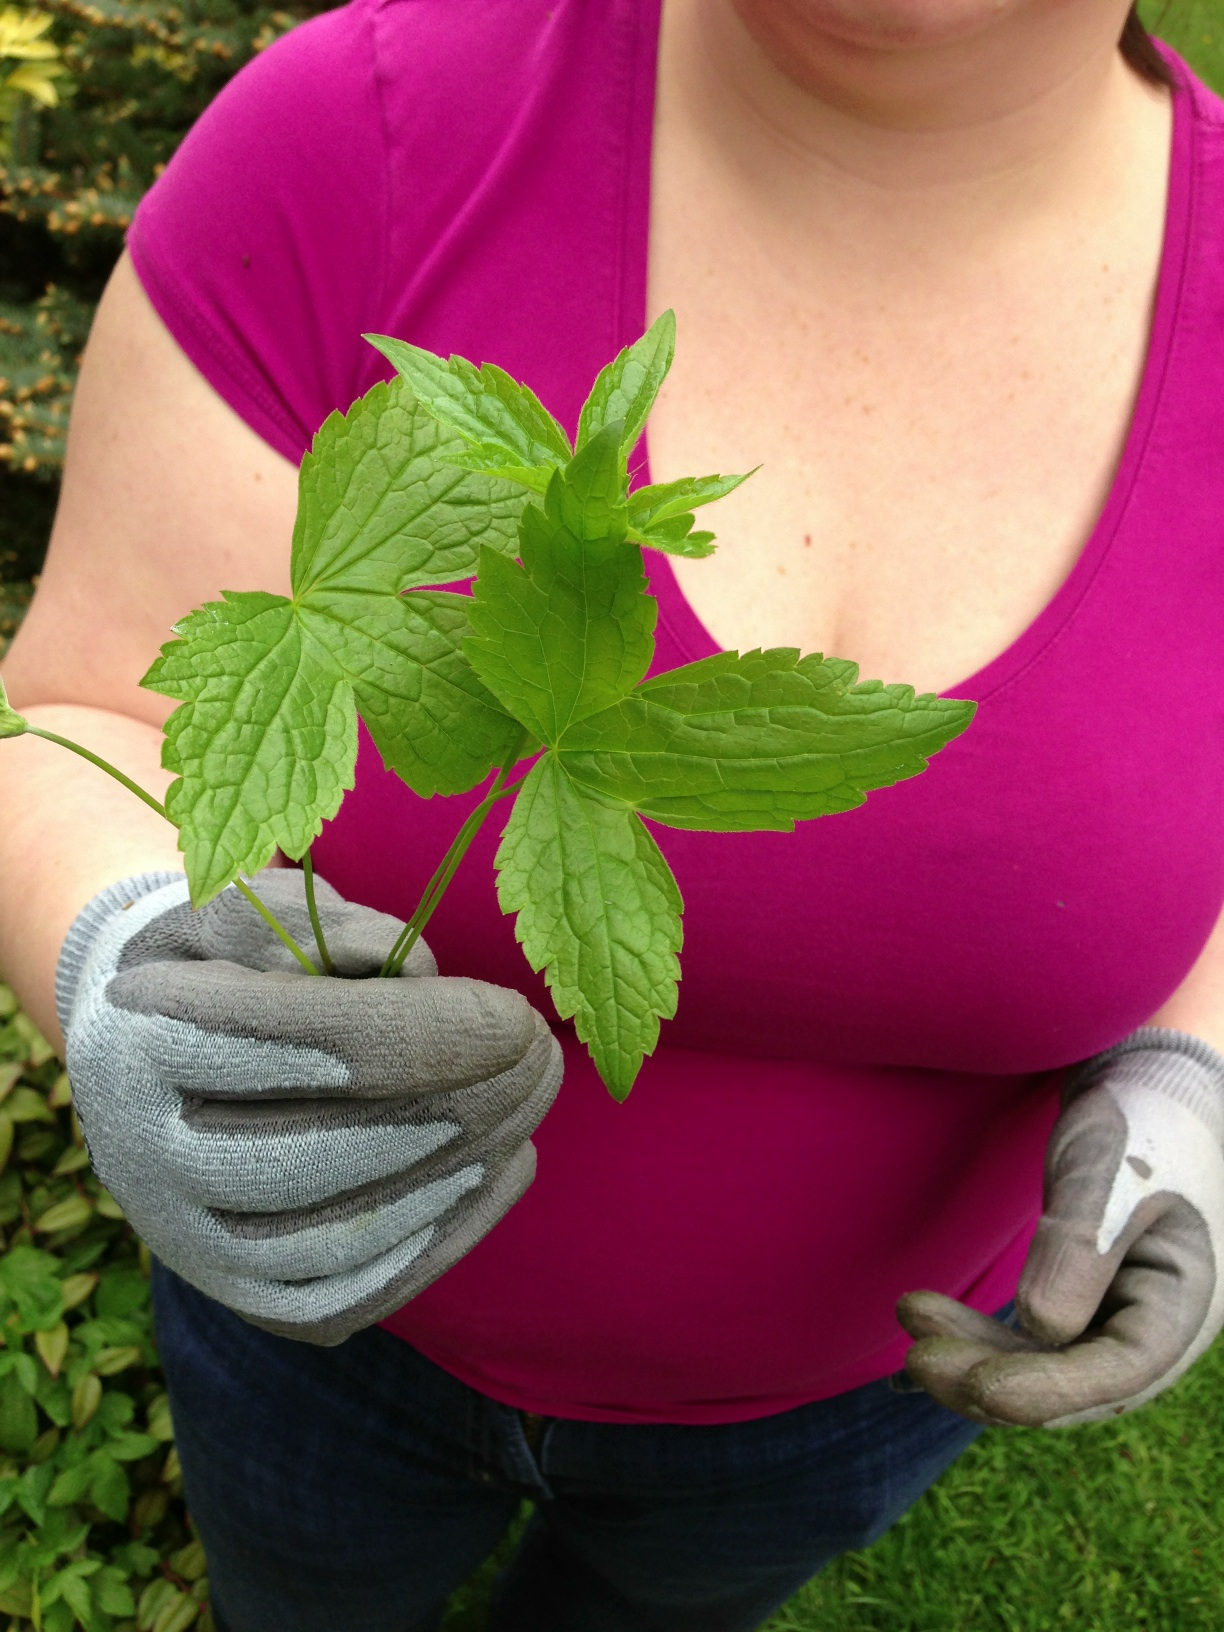Can you tell me more about the care requirements for this type of plant? Plants like the one shown typically thrive in well-drained soil with moderate sunlight. Regular watering is recommended, especially during dry periods, though it's important not to overwater as it may lead to root rot. Are there any common uses for this plant? Yes, if this is indeed a type of ginseng, it is often used in traditional medicine to boost energy, reduce stress, and increase immunity. It's also commonly used in teas or as a supplement. 